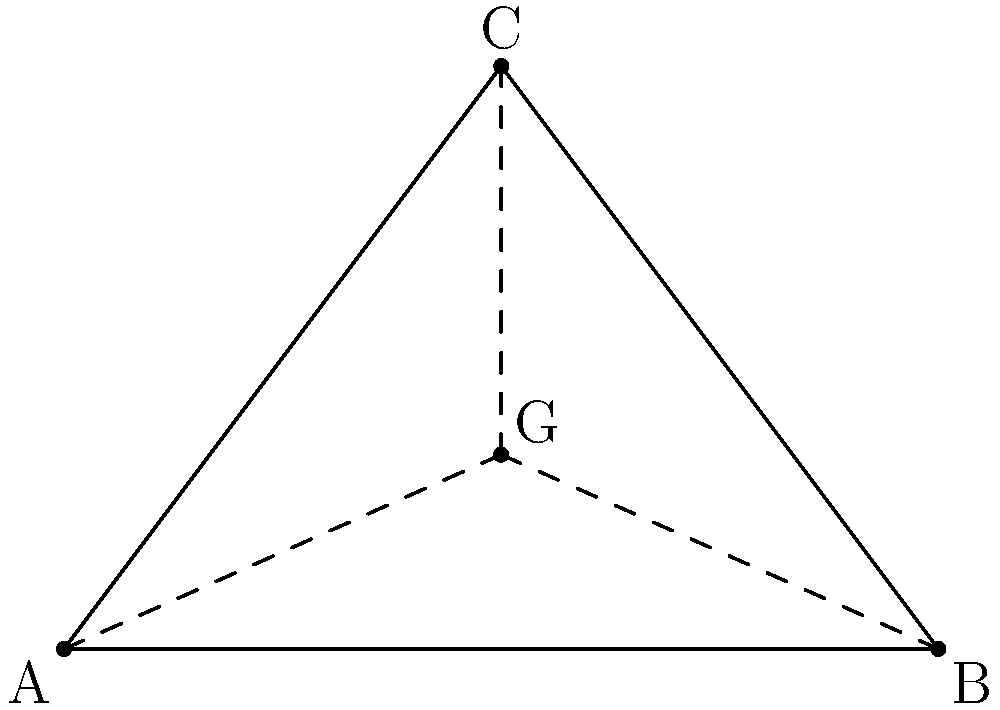In our business strategy meeting, we're using a triangular diagram to represent market segments. The vertices of the triangle are at coordinates A(0,0), B(6,0), and C(3,4). To find the optimal point for resource allocation, we need to determine the centroid of this triangle. Calculate the coordinates of the centroid. To find the centroid of a triangle given its vertices, we can follow these steps:

1) The centroid formula for a triangle with vertices $(x_1, y_1)$, $(x_2, y_2)$, and $(x_3, y_3)$ is:

   $G_x = \frac{x_1 + x_2 + x_3}{3}$ and $G_y = \frac{y_1 + y_2 + y_3}{3}$

2) We have the following coordinates:
   A(0,0), B(6,0), and C(3,4)

3) Let's calculate $G_x$:
   $$G_x = \frac{0 + 6 + 3}{3} = \frac{9}{3} = 3$$

4) Now, let's calculate $G_y$:
   $$G_y = \frac{0 + 0 + 4}{3} = \frac{4}{3} \approx 1.33$$

5) Therefore, the coordinates of the centroid G are (3, 4/3) or approximately (3, 1.33).
Answer: (3, 4/3) 